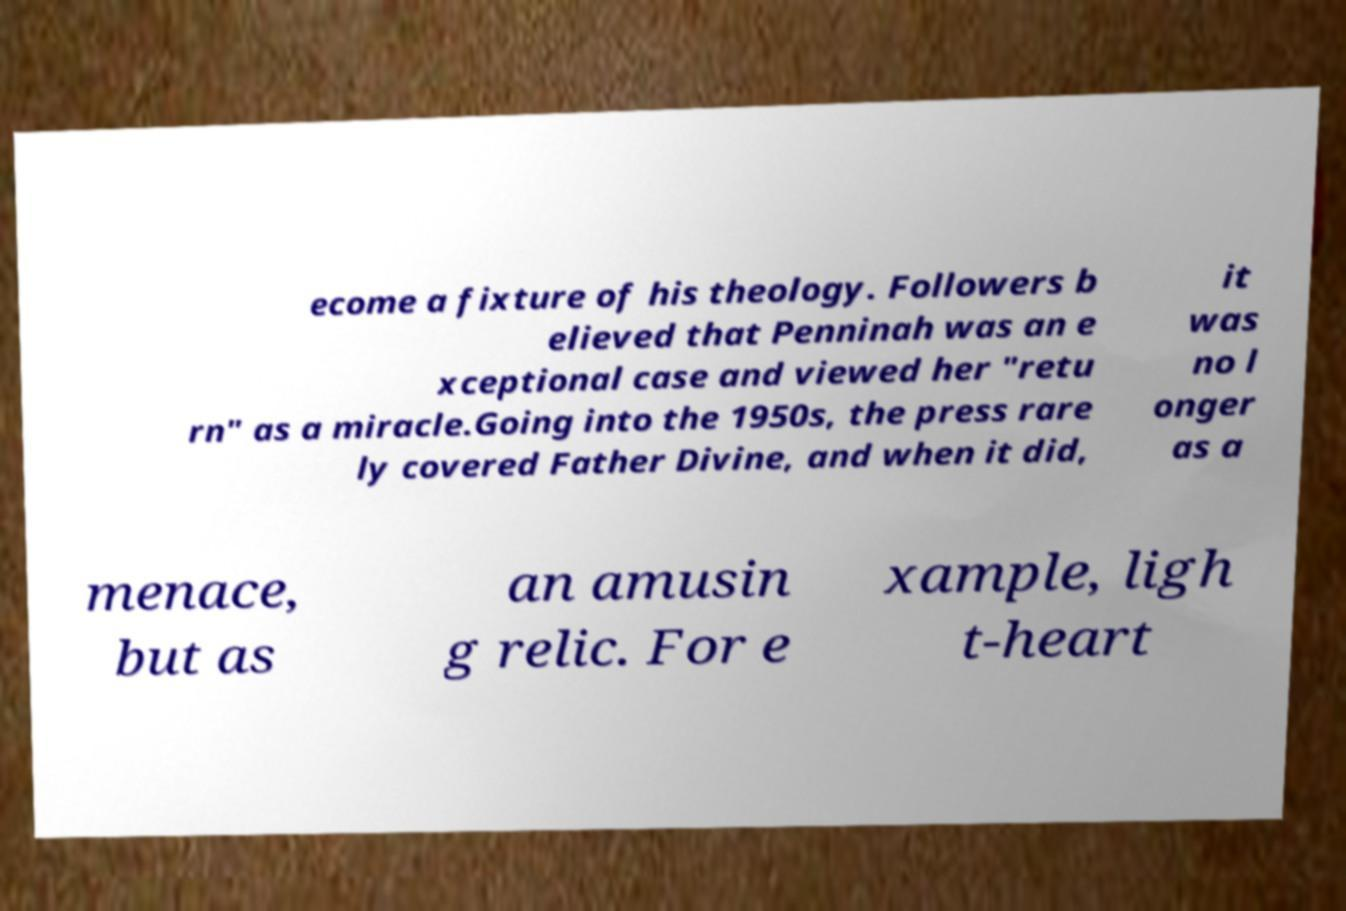Could you extract and type out the text from this image? ecome a fixture of his theology. Followers b elieved that Penninah was an e xceptional case and viewed her "retu rn" as a miracle.Going into the 1950s, the press rare ly covered Father Divine, and when it did, it was no l onger as a menace, but as an amusin g relic. For e xample, ligh t-heart 